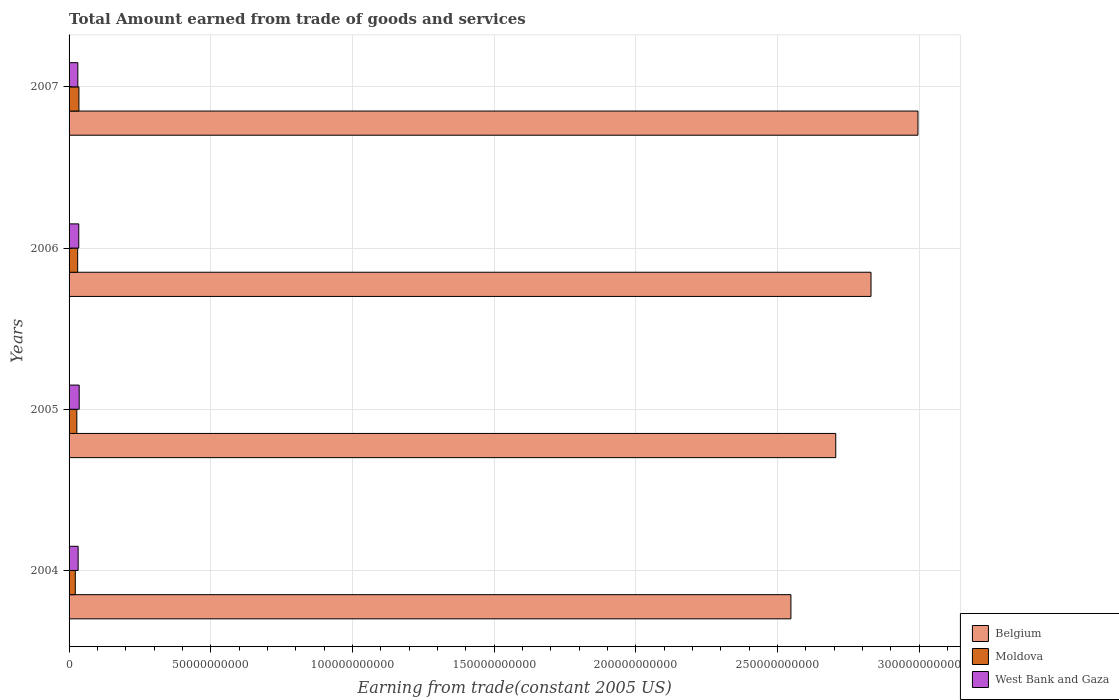Are the number of bars per tick equal to the number of legend labels?
Give a very brief answer. Yes. How many bars are there on the 4th tick from the bottom?
Your answer should be compact. 3. What is the label of the 3rd group of bars from the top?
Your answer should be compact. 2005. In how many cases, is the number of bars for a given year not equal to the number of legend labels?
Your answer should be very brief. 0. What is the total amount earned by trading goods and services in Moldova in 2007?
Your response must be concise. 3.48e+09. Across all years, what is the maximum total amount earned by trading goods and services in West Bank and Gaza?
Give a very brief answer. 3.58e+09. Across all years, what is the minimum total amount earned by trading goods and services in West Bank and Gaza?
Your response must be concise. 3.09e+09. In which year was the total amount earned by trading goods and services in West Bank and Gaza maximum?
Make the answer very short. 2005. In which year was the total amount earned by trading goods and services in Belgium minimum?
Offer a terse response. 2004. What is the total total amount earned by trading goods and services in Moldova in the graph?
Keep it short and to the point. 1.15e+1. What is the difference between the total amount earned by trading goods and services in West Bank and Gaza in 2004 and that in 2005?
Your response must be concise. -3.74e+08. What is the difference between the total amount earned by trading goods and services in Belgium in 2006 and the total amount earned by trading goods and services in Moldova in 2005?
Offer a very short reply. 2.80e+11. What is the average total amount earned by trading goods and services in Belgium per year?
Your answer should be very brief. 2.77e+11. In the year 2004, what is the difference between the total amount earned by trading goods and services in Moldova and total amount earned by trading goods and services in Belgium?
Offer a very short reply. -2.53e+11. In how many years, is the total amount earned by trading goods and services in West Bank and Gaza greater than 90000000000 US$?
Your answer should be compact. 0. What is the ratio of the total amount earned by trading goods and services in Moldova in 2004 to that in 2006?
Make the answer very short. 0.72. Is the total amount earned by trading goods and services in Moldova in 2005 less than that in 2006?
Your response must be concise. Yes. What is the difference between the highest and the second highest total amount earned by trading goods and services in Belgium?
Offer a very short reply. 1.66e+1. What is the difference between the highest and the lowest total amount earned by trading goods and services in West Bank and Gaza?
Offer a very short reply. 4.82e+08. Is the sum of the total amount earned by trading goods and services in Moldova in 2004 and 2006 greater than the maximum total amount earned by trading goods and services in West Bank and Gaza across all years?
Give a very brief answer. Yes. What does the 2nd bar from the top in 2007 represents?
Your response must be concise. Moldova. Is it the case that in every year, the sum of the total amount earned by trading goods and services in Moldova and total amount earned by trading goods and services in West Bank and Gaza is greater than the total amount earned by trading goods and services in Belgium?
Offer a terse response. No. How many bars are there?
Keep it short and to the point. 12. Are all the bars in the graph horizontal?
Offer a terse response. Yes. Does the graph contain grids?
Ensure brevity in your answer.  Yes. What is the title of the graph?
Your answer should be very brief. Total Amount earned from trade of goods and services. Does "Yemen, Rep." appear as one of the legend labels in the graph?
Give a very brief answer. No. What is the label or title of the X-axis?
Make the answer very short. Earning from trade(constant 2005 US). What is the Earning from trade(constant 2005 US) of Belgium in 2004?
Provide a succinct answer. 2.55e+11. What is the Earning from trade(constant 2005 US) of Moldova in 2004?
Ensure brevity in your answer.  2.20e+09. What is the Earning from trade(constant 2005 US) in West Bank and Gaza in 2004?
Your answer should be compact. 3.20e+09. What is the Earning from trade(constant 2005 US) in Belgium in 2005?
Keep it short and to the point. 2.71e+11. What is the Earning from trade(constant 2005 US) of Moldova in 2005?
Ensure brevity in your answer.  2.74e+09. What is the Earning from trade(constant 2005 US) of West Bank and Gaza in 2005?
Ensure brevity in your answer.  3.58e+09. What is the Earning from trade(constant 2005 US) in Belgium in 2006?
Provide a short and direct response. 2.83e+11. What is the Earning from trade(constant 2005 US) in Moldova in 2006?
Give a very brief answer. 3.04e+09. What is the Earning from trade(constant 2005 US) in West Bank and Gaza in 2006?
Provide a short and direct response. 3.42e+09. What is the Earning from trade(constant 2005 US) in Belgium in 2007?
Your answer should be compact. 3.00e+11. What is the Earning from trade(constant 2005 US) in Moldova in 2007?
Give a very brief answer. 3.48e+09. What is the Earning from trade(constant 2005 US) in West Bank and Gaza in 2007?
Give a very brief answer. 3.09e+09. Across all years, what is the maximum Earning from trade(constant 2005 US) in Belgium?
Ensure brevity in your answer.  3.00e+11. Across all years, what is the maximum Earning from trade(constant 2005 US) in Moldova?
Ensure brevity in your answer.  3.48e+09. Across all years, what is the maximum Earning from trade(constant 2005 US) in West Bank and Gaza?
Offer a terse response. 3.58e+09. Across all years, what is the minimum Earning from trade(constant 2005 US) of Belgium?
Make the answer very short. 2.55e+11. Across all years, what is the minimum Earning from trade(constant 2005 US) in Moldova?
Your response must be concise. 2.20e+09. Across all years, what is the minimum Earning from trade(constant 2005 US) in West Bank and Gaza?
Provide a short and direct response. 3.09e+09. What is the total Earning from trade(constant 2005 US) of Belgium in the graph?
Keep it short and to the point. 1.11e+12. What is the total Earning from trade(constant 2005 US) of Moldova in the graph?
Offer a very short reply. 1.15e+1. What is the total Earning from trade(constant 2005 US) in West Bank and Gaza in the graph?
Provide a succinct answer. 1.33e+1. What is the difference between the Earning from trade(constant 2005 US) in Belgium in 2004 and that in 2005?
Keep it short and to the point. -1.58e+1. What is the difference between the Earning from trade(constant 2005 US) of Moldova in 2004 and that in 2005?
Ensure brevity in your answer.  -5.41e+08. What is the difference between the Earning from trade(constant 2005 US) in West Bank and Gaza in 2004 and that in 2005?
Make the answer very short. -3.74e+08. What is the difference between the Earning from trade(constant 2005 US) of Belgium in 2004 and that in 2006?
Make the answer very short. -2.83e+1. What is the difference between the Earning from trade(constant 2005 US) of Moldova in 2004 and that in 2006?
Provide a succinct answer. -8.40e+08. What is the difference between the Earning from trade(constant 2005 US) in West Bank and Gaza in 2004 and that in 2006?
Offer a very short reply. -2.23e+08. What is the difference between the Earning from trade(constant 2005 US) in Belgium in 2004 and that in 2007?
Ensure brevity in your answer.  -4.48e+1. What is the difference between the Earning from trade(constant 2005 US) in Moldova in 2004 and that in 2007?
Offer a terse response. -1.28e+09. What is the difference between the Earning from trade(constant 2005 US) in West Bank and Gaza in 2004 and that in 2007?
Your response must be concise. 1.08e+08. What is the difference between the Earning from trade(constant 2005 US) of Belgium in 2005 and that in 2006?
Provide a succinct answer. -1.24e+1. What is the difference between the Earning from trade(constant 2005 US) in Moldova in 2005 and that in 2006?
Offer a very short reply. -2.98e+08. What is the difference between the Earning from trade(constant 2005 US) of West Bank and Gaza in 2005 and that in 2006?
Offer a very short reply. 1.51e+08. What is the difference between the Earning from trade(constant 2005 US) of Belgium in 2005 and that in 2007?
Provide a short and direct response. -2.90e+1. What is the difference between the Earning from trade(constant 2005 US) in Moldova in 2005 and that in 2007?
Offer a terse response. -7.42e+08. What is the difference between the Earning from trade(constant 2005 US) of West Bank and Gaza in 2005 and that in 2007?
Provide a short and direct response. 4.82e+08. What is the difference between the Earning from trade(constant 2005 US) in Belgium in 2006 and that in 2007?
Offer a terse response. -1.66e+1. What is the difference between the Earning from trade(constant 2005 US) in Moldova in 2006 and that in 2007?
Give a very brief answer. -4.43e+08. What is the difference between the Earning from trade(constant 2005 US) in West Bank and Gaza in 2006 and that in 2007?
Your answer should be very brief. 3.31e+08. What is the difference between the Earning from trade(constant 2005 US) in Belgium in 2004 and the Earning from trade(constant 2005 US) in Moldova in 2005?
Keep it short and to the point. 2.52e+11. What is the difference between the Earning from trade(constant 2005 US) of Belgium in 2004 and the Earning from trade(constant 2005 US) of West Bank and Gaza in 2005?
Provide a short and direct response. 2.51e+11. What is the difference between the Earning from trade(constant 2005 US) in Moldova in 2004 and the Earning from trade(constant 2005 US) in West Bank and Gaza in 2005?
Provide a succinct answer. -1.38e+09. What is the difference between the Earning from trade(constant 2005 US) in Belgium in 2004 and the Earning from trade(constant 2005 US) in Moldova in 2006?
Make the answer very short. 2.52e+11. What is the difference between the Earning from trade(constant 2005 US) of Belgium in 2004 and the Earning from trade(constant 2005 US) of West Bank and Gaza in 2006?
Offer a very short reply. 2.51e+11. What is the difference between the Earning from trade(constant 2005 US) of Moldova in 2004 and the Earning from trade(constant 2005 US) of West Bank and Gaza in 2006?
Provide a short and direct response. -1.23e+09. What is the difference between the Earning from trade(constant 2005 US) of Belgium in 2004 and the Earning from trade(constant 2005 US) of Moldova in 2007?
Provide a short and direct response. 2.51e+11. What is the difference between the Earning from trade(constant 2005 US) in Belgium in 2004 and the Earning from trade(constant 2005 US) in West Bank and Gaza in 2007?
Offer a terse response. 2.52e+11. What is the difference between the Earning from trade(constant 2005 US) of Moldova in 2004 and the Earning from trade(constant 2005 US) of West Bank and Gaza in 2007?
Provide a succinct answer. -8.96e+08. What is the difference between the Earning from trade(constant 2005 US) of Belgium in 2005 and the Earning from trade(constant 2005 US) of Moldova in 2006?
Ensure brevity in your answer.  2.68e+11. What is the difference between the Earning from trade(constant 2005 US) in Belgium in 2005 and the Earning from trade(constant 2005 US) in West Bank and Gaza in 2006?
Offer a very short reply. 2.67e+11. What is the difference between the Earning from trade(constant 2005 US) of Moldova in 2005 and the Earning from trade(constant 2005 US) of West Bank and Gaza in 2006?
Offer a terse response. -6.85e+08. What is the difference between the Earning from trade(constant 2005 US) of Belgium in 2005 and the Earning from trade(constant 2005 US) of Moldova in 2007?
Your answer should be very brief. 2.67e+11. What is the difference between the Earning from trade(constant 2005 US) in Belgium in 2005 and the Earning from trade(constant 2005 US) in West Bank and Gaza in 2007?
Offer a very short reply. 2.68e+11. What is the difference between the Earning from trade(constant 2005 US) in Moldova in 2005 and the Earning from trade(constant 2005 US) in West Bank and Gaza in 2007?
Ensure brevity in your answer.  -3.54e+08. What is the difference between the Earning from trade(constant 2005 US) in Belgium in 2006 and the Earning from trade(constant 2005 US) in Moldova in 2007?
Offer a terse response. 2.80e+11. What is the difference between the Earning from trade(constant 2005 US) of Belgium in 2006 and the Earning from trade(constant 2005 US) of West Bank and Gaza in 2007?
Offer a very short reply. 2.80e+11. What is the difference between the Earning from trade(constant 2005 US) of Moldova in 2006 and the Earning from trade(constant 2005 US) of West Bank and Gaza in 2007?
Provide a succinct answer. -5.60e+07. What is the average Earning from trade(constant 2005 US) of Belgium per year?
Offer a very short reply. 2.77e+11. What is the average Earning from trade(constant 2005 US) of Moldova per year?
Keep it short and to the point. 2.86e+09. What is the average Earning from trade(constant 2005 US) in West Bank and Gaza per year?
Offer a terse response. 3.32e+09. In the year 2004, what is the difference between the Earning from trade(constant 2005 US) of Belgium and Earning from trade(constant 2005 US) of Moldova?
Your answer should be very brief. 2.53e+11. In the year 2004, what is the difference between the Earning from trade(constant 2005 US) in Belgium and Earning from trade(constant 2005 US) in West Bank and Gaza?
Provide a short and direct response. 2.52e+11. In the year 2004, what is the difference between the Earning from trade(constant 2005 US) of Moldova and Earning from trade(constant 2005 US) of West Bank and Gaza?
Keep it short and to the point. -1.00e+09. In the year 2005, what is the difference between the Earning from trade(constant 2005 US) in Belgium and Earning from trade(constant 2005 US) in Moldova?
Your answer should be very brief. 2.68e+11. In the year 2005, what is the difference between the Earning from trade(constant 2005 US) in Belgium and Earning from trade(constant 2005 US) in West Bank and Gaza?
Give a very brief answer. 2.67e+11. In the year 2005, what is the difference between the Earning from trade(constant 2005 US) in Moldova and Earning from trade(constant 2005 US) in West Bank and Gaza?
Provide a succinct answer. -8.36e+08. In the year 2006, what is the difference between the Earning from trade(constant 2005 US) of Belgium and Earning from trade(constant 2005 US) of Moldova?
Make the answer very short. 2.80e+11. In the year 2006, what is the difference between the Earning from trade(constant 2005 US) of Belgium and Earning from trade(constant 2005 US) of West Bank and Gaza?
Your response must be concise. 2.80e+11. In the year 2006, what is the difference between the Earning from trade(constant 2005 US) of Moldova and Earning from trade(constant 2005 US) of West Bank and Gaza?
Provide a short and direct response. -3.87e+08. In the year 2007, what is the difference between the Earning from trade(constant 2005 US) in Belgium and Earning from trade(constant 2005 US) in Moldova?
Your answer should be compact. 2.96e+11. In the year 2007, what is the difference between the Earning from trade(constant 2005 US) of Belgium and Earning from trade(constant 2005 US) of West Bank and Gaza?
Offer a very short reply. 2.97e+11. In the year 2007, what is the difference between the Earning from trade(constant 2005 US) in Moldova and Earning from trade(constant 2005 US) in West Bank and Gaza?
Your response must be concise. 3.87e+08. What is the ratio of the Earning from trade(constant 2005 US) in Belgium in 2004 to that in 2005?
Your answer should be very brief. 0.94. What is the ratio of the Earning from trade(constant 2005 US) in Moldova in 2004 to that in 2005?
Keep it short and to the point. 0.8. What is the ratio of the Earning from trade(constant 2005 US) in West Bank and Gaza in 2004 to that in 2005?
Keep it short and to the point. 0.9. What is the ratio of the Earning from trade(constant 2005 US) in Belgium in 2004 to that in 2006?
Your answer should be very brief. 0.9. What is the ratio of the Earning from trade(constant 2005 US) of Moldova in 2004 to that in 2006?
Your answer should be compact. 0.72. What is the ratio of the Earning from trade(constant 2005 US) in West Bank and Gaza in 2004 to that in 2006?
Offer a terse response. 0.93. What is the ratio of the Earning from trade(constant 2005 US) in Belgium in 2004 to that in 2007?
Offer a very short reply. 0.85. What is the ratio of the Earning from trade(constant 2005 US) in Moldova in 2004 to that in 2007?
Offer a very short reply. 0.63. What is the ratio of the Earning from trade(constant 2005 US) of West Bank and Gaza in 2004 to that in 2007?
Provide a short and direct response. 1.03. What is the ratio of the Earning from trade(constant 2005 US) of Belgium in 2005 to that in 2006?
Provide a succinct answer. 0.96. What is the ratio of the Earning from trade(constant 2005 US) of Moldova in 2005 to that in 2006?
Offer a terse response. 0.9. What is the ratio of the Earning from trade(constant 2005 US) in West Bank and Gaza in 2005 to that in 2006?
Offer a very short reply. 1.04. What is the ratio of the Earning from trade(constant 2005 US) of Belgium in 2005 to that in 2007?
Your response must be concise. 0.9. What is the ratio of the Earning from trade(constant 2005 US) in Moldova in 2005 to that in 2007?
Offer a terse response. 0.79. What is the ratio of the Earning from trade(constant 2005 US) of West Bank and Gaza in 2005 to that in 2007?
Your response must be concise. 1.16. What is the ratio of the Earning from trade(constant 2005 US) of Belgium in 2006 to that in 2007?
Make the answer very short. 0.94. What is the ratio of the Earning from trade(constant 2005 US) of Moldova in 2006 to that in 2007?
Provide a short and direct response. 0.87. What is the ratio of the Earning from trade(constant 2005 US) in West Bank and Gaza in 2006 to that in 2007?
Ensure brevity in your answer.  1.11. What is the difference between the highest and the second highest Earning from trade(constant 2005 US) in Belgium?
Your answer should be very brief. 1.66e+1. What is the difference between the highest and the second highest Earning from trade(constant 2005 US) of Moldova?
Offer a terse response. 4.43e+08. What is the difference between the highest and the second highest Earning from trade(constant 2005 US) of West Bank and Gaza?
Your answer should be compact. 1.51e+08. What is the difference between the highest and the lowest Earning from trade(constant 2005 US) in Belgium?
Offer a terse response. 4.48e+1. What is the difference between the highest and the lowest Earning from trade(constant 2005 US) in Moldova?
Your answer should be very brief. 1.28e+09. What is the difference between the highest and the lowest Earning from trade(constant 2005 US) of West Bank and Gaza?
Ensure brevity in your answer.  4.82e+08. 